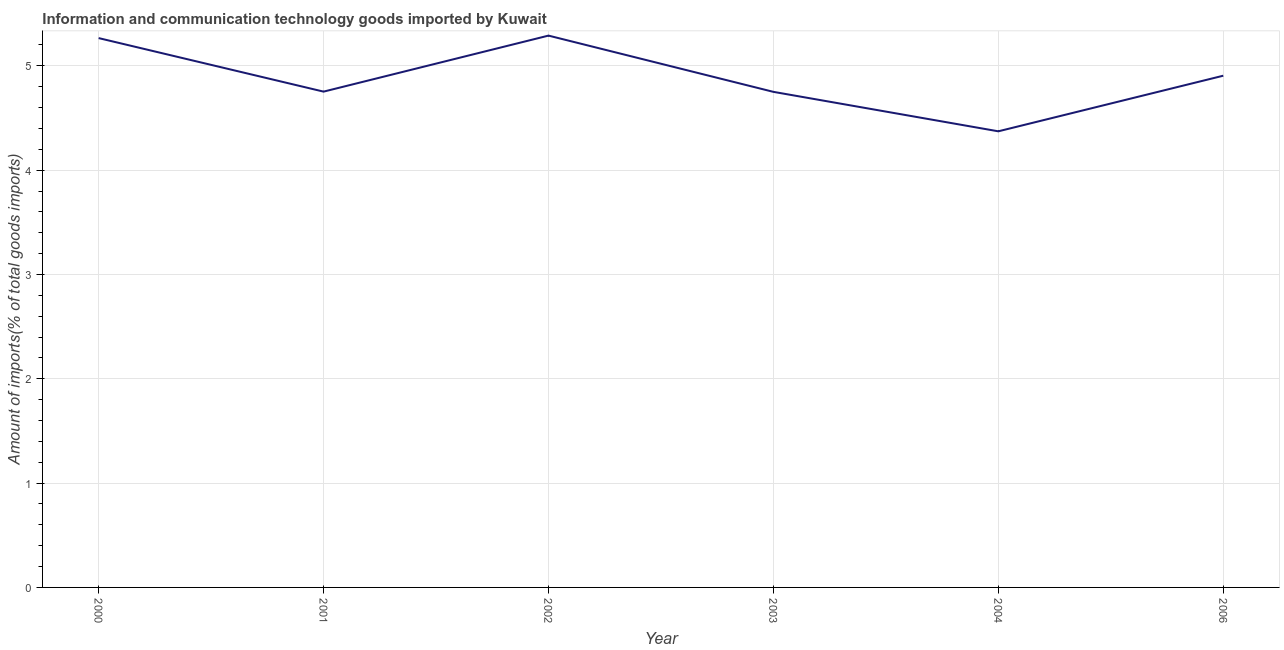What is the amount of ict goods imports in 2003?
Provide a succinct answer. 4.75. Across all years, what is the maximum amount of ict goods imports?
Keep it short and to the point. 5.29. Across all years, what is the minimum amount of ict goods imports?
Ensure brevity in your answer.  4.37. What is the sum of the amount of ict goods imports?
Provide a succinct answer. 29.34. What is the difference between the amount of ict goods imports in 2001 and 2004?
Keep it short and to the point. 0.38. What is the average amount of ict goods imports per year?
Provide a short and direct response. 4.89. What is the median amount of ict goods imports?
Provide a succinct answer. 4.83. In how many years, is the amount of ict goods imports greater than 4.8 %?
Keep it short and to the point. 3. What is the ratio of the amount of ict goods imports in 2001 to that in 2004?
Keep it short and to the point. 1.09. What is the difference between the highest and the second highest amount of ict goods imports?
Your answer should be very brief. 0.02. Is the sum of the amount of ict goods imports in 2001 and 2006 greater than the maximum amount of ict goods imports across all years?
Your answer should be very brief. Yes. What is the difference between the highest and the lowest amount of ict goods imports?
Make the answer very short. 0.92. In how many years, is the amount of ict goods imports greater than the average amount of ict goods imports taken over all years?
Your answer should be very brief. 3. How many lines are there?
Give a very brief answer. 1. How many years are there in the graph?
Give a very brief answer. 6. Does the graph contain grids?
Ensure brevity in your answer.  Yes. What is the title of the graph?
Your response must be concise. Information and communication technology goods imported by Kuwait. What is the label or title of the X-axis?
Provide a short and direct response. Year. What is the label or title of the Y-axis?
Your answer should be very brief. Amount of imports(% of total goods imports). What is the Amount of imports(% of total goods imports) of 2000?
Ensure brevity in your answer.  5.27. What is the Amount of imports(% of total goods imports) of 2001?
Offer a very short reply. 4.75. What is the Amount of imports(% of total goods imports) of 2002?
Your response must be concise. 5.29. What is the Amount of imports(% of total goods imports) in 2003?
Give a very brief answer. 4.75. What is the Amount of imports(% of total goods imports) of 2004?
Offer a terse response. 4.37. What is the Amount of imports(% of total goods imports) in 2006?
Your answer should be very brief. 4.91. What is the difference between the Amount of imports(% of total goods imports) in 2000 and 2001?
Give a very brief answer. 0.51. What is the difference between the Amount of imports(% of total goods imports) in 2000 and 2002?
Provide a short and direct response. -0.02. What is the difference between the Amount of imports(% of total goods imports) in 2000 and 2003?
Offer a terse response. 0.52. What is the difference between the Amount of imports(% of total goods imports) in 2000 and 2004?
Offer a very short reply. 0.89. What is the difference between the Amount of imports(% of total goods imports) in 2000 and 2006?
Provide a succinct answer. 0.36. What is the difference between the Amount of imports(% of total goods imports) in 2001 and 2002?
Make the answer very short. -0.54. What is the difference between the Amount of imports(% of total goods imports) in 2001 and 2003?
Give a very brief answer. 0. What is the difference between the Amount of imports(% of total goods imports) in 2001 and 2004?
Give a very brief answer. 0.38. What is the difference between the Amount of imports(% of total goods imports) in 2001 and 2006?
Give a very brief answer. -0.15. What is the difference between the Amount of imports(% of total goods imports) in 2002 and 2003?
Provide a short and direct response. 0.54. What is the difference between the Amount of imports(% of total goods imports) in 2002 and 2004?
Provide a succinct answer. 0.92. What is the difference between the Amount of imports(% of total goods imports) in 2002 and 2006?
Provide a succinct answer. 0.38. What is the difference between the Amount of imports(% of total goods imports) in 2003 and 2004?
Offer a terse response. 0.38. What is the difference between the Amount of imports(% of total goods imports) in 2003 and 2006?
Make the answer very short. -0.15. What is the difference between the Amount of imports(% of total goods imports) in 2004 and 2006?
Provide a succinct answer. -0.53. What is the ratio of the Amount of imports(% of total goods imports) in 2000 to that in 2001?
Make the answer very short. 1.11. What is the ratio of the Amount of imports(% of total goods imports) in 2000 to that in 2003?
Offer a very short reply. 1.11. What is the ratio of the Amount of imports(% of total goods imports) in 2000 to that in 2004?
Offer a terse response. 1.2. What is the ratio of the Amount of imports(% of total goods imports) in 2000 to that in 2006?
Your response must be concise. 1.07. What is the ratio of the Amount of imports(% of total goods imports) in 2001 to that in 2002?
Give a very brief answer. 0.9. What is the ratio of the Amount of imports(% of total goods imports) in 2001 to that in 2003?
Provide a short and direct response. 1. What is the ratio of the Amount of imports(% of total goods imports) in 2001 to that in 2004?
Give a very brief answer. 1.09. What is the ratio of the Amount of imports(% of total goods imports) in 2002 to that in 2003?
Offer a terse response. 1.11. What is the ratio of the Amount of imports(% of total goods imports) in 2002 to that in 2004?
Provide a succinct answer. 1.21. What is the ratio of the Amount of imports(% of total goods imports) in 2002 to that in 2006?
Make the answer very short. 1.08. What is the ratio of the Amount of imports(% of total goods imports) in 2003 to that in 2004?
Ensure brevity in your answer.  1.09. What is the ratio of the Amount of imports(% of total goods imports) in 2004 to that in 2006?
Provide a short and direct response. 0.89. 